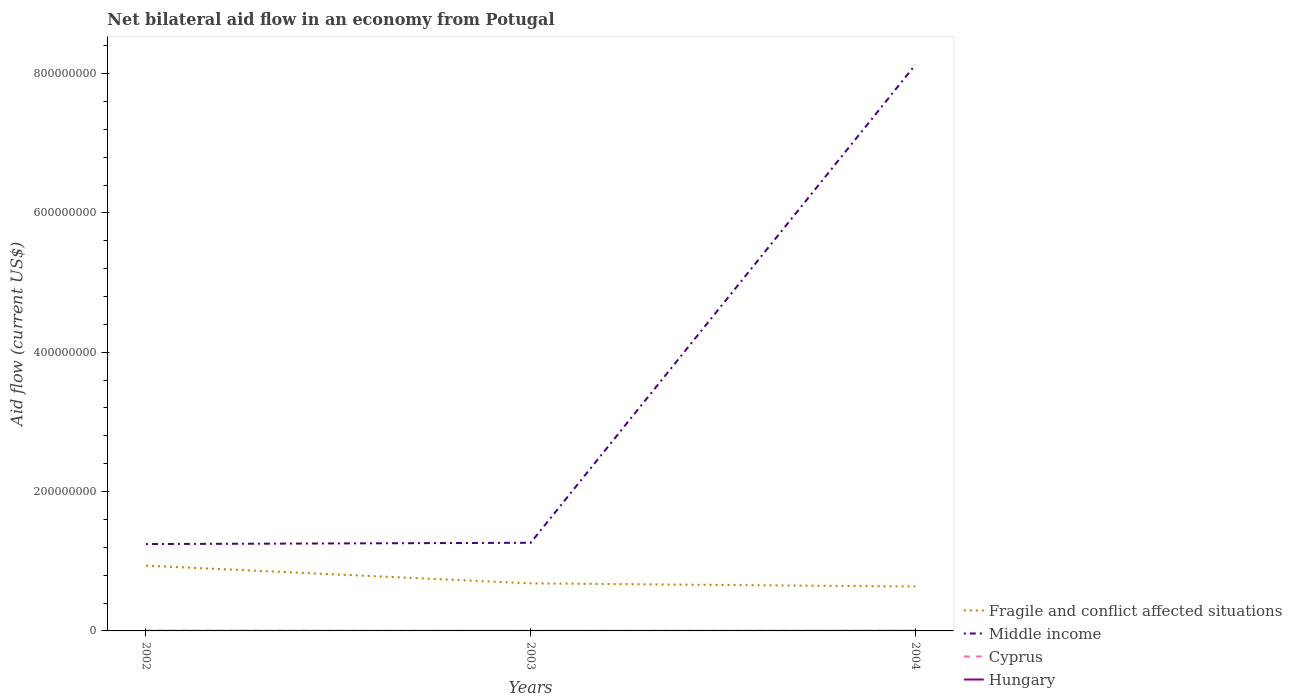Across all years, what is the maximum net bilateral aid flow in Fragile and conflict affected situations?
Provide a short and direct response. 6.37e+07. What is the difference between the highest and the second highest net bilateral aid flow in Fragile and conflict affected situations?
Provide a short and direct response. 3.00e+07. What is the difference between the highest and the lowest net bilateral aid flow in Fragile and conflict affected situations?
Keep it short and to the point. 1. How many lines are there?
Provide a succinct answer. 4. How many years are there in the graph?
Your response must be concise. 3. What is the difference between two consecutive major ticks on the Y-axis?
Provide a short and direct response. 2.00e+08. How many legend labels are there?
Your answer should be compact. 4. What is the title of the graph?
Your answer should be very brief. Net bilateral aid flow in an economy from Potugal. Does "Hong Kong" appear as one of the legend labels in the graph?
Your answer should be very brief. No. What is the label or title of the X-axis?
Ensure brevity in your answer.  Years. What is the Aid flow (current US$) in Fragile and conflict affected situations in 2002?
Your answer should be compact. 9.37e+07. What is the Aid flow (current US$) in Middle income in 2002?
Offer a terse response. 1.25e+08. What is the Aid flow (current US$) of Hungary in 2002?
Make the answer very short. 7.00e+04. What is the Aid flow (current US$) of Fragile and conflict affected situations in 2003?
Give a very brief answer. 6.82e+07. What is the Aid flow (current US$) in Middle income in 2003?
Ensure brevity in your answer.  1.27e+08. What is the Aid flow (current US$) of Fragile and conflict affected situations in 2004?
Give a very brief answer. 6.37e+07. What is the Aid flow (current US$) of Middle income in 2004?
Your answer should be very brief. 8.12e+08. What is the Aid flow (current US$) in Cyprus in 2004?
Provide a short and direct response. 1.10e+05. What is the Aid flow (current US$) in Hungary in 2004?
Give a very brief answer. 8.00e+04. Across all years, what is the maximum Aid flow (current US$) in Fragile and conflict affected situations?
Provide a short and direct response. 9.37e+07. Across all years, what is the maximum Aid flow (current US$) in Middle income?
Give a very brief answer. 8.12e+08. Across all years, what is the maximum Aid flow (current US$) in Cyprus?
Provide a succinct answer. 1.90e+05. Across all years, what is the maximum Aid flow (current US$) in Hungary?
Provide a succinct answer. 8.00e+04. Across all years, what is the minimum Aid flow (current US$) of Fragile and conflict affected situations?
Your answer should be very brief. 6.37e+07. Across all years, what is the minimum Aid flow (current US$) of Middle income?
Your answer should be compact. 1.25e+08. What is the total Aid flow (current US$) in Fragile and conflict affected situations in the graph?
Provide a succinct answer. 2.26e+08. What is the total Aid flow (current US$) in Middle income in the graph?
Keep it short and to the point. 1.06e+09. What is the total Aid flow (current US$) in Cyprus in the graph?
Offer a terse response. 3.30e+05. What is the difference between the Aid flow (current US$) of Fragile and conflict affected situations in 2002 and that in 2003?
Your answer should be compact. 2.54e+07. What is the difference between the Aid flow (current US$) in Middle income in 2002 and that in 2003?
Make the answer very short. -1.84e+06. What is the difference between the Aid flow (current US$) of Cyprus in 2002 and that in 2003?
Make the answer very short. 1.60e+05. What is the difference between the Aid flow (current US$) in Fragile and conflict affected situations in 2002 and that in 2004?
Give a very brief answer. 3.00e+07. What is the difference between the Aid flow (current US$) of Middle income in 2002 and that in 2004?
Give a very brief answer. -6.88e+08. What is the difference between the Aid flow (current US$) of Fragile and conflict affected situations in 2003 and that in 2004?
Ensure brevity in your answer.  4.52e+06. What is the difference between the Aid flow (current US$) of Middle income in 2003 and that in 2004?
Offer a terse response. -6.86e+08. What is the difference between the Aid flow (current US$) of Hungary in 2003 and that in 2004?
Offer a very short reply. -7.00e+04. What is the difference between the Aid flow (current US$) in Fragile and conflict affected situations in 2002 and the Aid flow (current US$) in Middle income in 2003?
Your answer should be very brief. -3.28e+07. What is the difference between the Aid flow (current US$) of Fragile and conflict affected situations in 2002 and the Aid flow (current US$) of Cyprus in 2003?
Keep it short and to the point. 9.36e+07. What is the difference between the Aid flow (current US$) in Fragile and conflict affected situations in 2002 and the Aid flow (current US$) in Hungary in 2003?
Your answer should be very brief. 9.36e+07. What is the difference between the Aid flow (current US$) in Middle income in 2002 and the Aid flow (current US$) in Cyprus in 2003?
Ensure brevity in your answer.  1.25e+08. What is the difference between the Aid flow (current US$) of Middle income in 2002 and the Aid flow (current US$) of Hungary in 2003?
Offer a very short reply. 1.25e+08. What is the difference between the Aid flow (current US$) of Cyprus in 2002 and the Aid flow (current US$) of Hungary in 2003?
Offer a terse response. 1.80e+05. What is the difference between the Aid flow (current US$) in Fragile and conflict affected situations in 2002 and the Aid flow (current US$) in Middle income in 2004?
Ensure brevity in your answer.  -7.19e+08. What is the difference between the Aid flow (current US$) of Fragile and conflict affected situations in 2002 and the Aid flow (current US$) of Cyprus in 2004?
Your answer should be compact. 9.36e+07. What is the difference between the Aid flow (current US$) in Fragile and conflict affected situations in 2002 and the Aid flow (current US$) in Hungary in 2004?
Provide a short and direct response. 9.36e+07. What is the difference between the Aid flow (current US$) of Middle income in 2002 and the Aid flow (current US$) of Cyprus in 2004?
Offer a terse response. 1.25e+08. What is the difference between the Aid flow (current US$) of Middle income in 2002 and the Aid flow (current US$) of Hungary in 2004?
Your response must be concise. 1.25e+08. What is the difference between the Aid flow (current US$) in Cyprus in 2002 and the Aid flow (current US$) in Hungary in 2004?
Make the answer very short. 1.10e+05. What is the difference between the Aid flow (current US$) in Fragile and conflict affected situations in 2003 and the Aid flow (current US$) in Middle income in 2004?
Your response must be concise. -7.44e+08. What is the difference between the Aid flow (current US$) in Fragile and conflict affected situations in 2003 and the Aid flow (current US$) in Cyprus in 2004?
Give a very brief answer. 6.81e+07. What is the difference between the Aid flow (current US$) in Fragile and conflict affected situations in 2003 and the Aid flow (current US$) in Hungary in 2004?
Keep it short and to the point. 6.82e+07. What is the difference between the Aid flow (current US$) in Middle income in 2003 and the Aid flow (current US$) in Cyprus in 2004?
Give a very brief answer. 1.26e+08. What is the difference between the Aid flow (current US$) of Middle income in 2003 and the Aid flow (current US$) of Hungary in 2004?
Give a very brief answer. 1.26e+08. What is the difference between the Aid flow (current US$) of Cyprus in 2003 and the Aid flow (current US$) of Hungary in 2004?
Give a very brief answer. -5.00e+04. What is the average Aid flow (current US$) of Fragile and conflict affected situations per year?
Provide a short and direct response. 7.52e+07. What is the average Aid flow (current US$) of Middle income per year?
Your response must be concise. 3.55e+08. What is the average Aid flow (current US$) in Hungary per year?
Make the answer very short. 5.33e+04. In the year 2002, what is the difference between the Aid flow (current US$) in Fragile and conflict affected situations and Aid flow (current US$) in Middle income?
Provide a succinct answer. -3.10e+07. In the year 2002, what is the difference between the Aid flow (current US$) of Fragile and conflict affected situations and Aid flow (current US$) of Cyprus?
Provide a short and direct response. 9.35e+07. In the year 2002, what is the difference between the Aid flow (current US$) of Fragile and conflict affected situations and Aid flow (current US$) of Hungary?
Your answer should be compact. 9.36e+07. In the year 2002, what is the difference between the Aid flow (current US$) in Middle income and Aid flow (current US$) in Cyprus?
Provide a succinct answer. 1.24e+08. In the year 2002, what is the difference between the Aid flow (current US$) in Middle income and Aid flow (current US$) in Hungary?
Keep it short and to the point. 1.25e+08. In the year 2003, what is the difference between the Aid flow (current US$) in Fragile and conflict affected situations and Aid flow (current US$) in Middle income?
Your answer should be compact. -5.83e+07. In the year 2003, what is the difference between the Aid flow (current US$) of Fragile and conflict affected situations and Aid flow (current US$) of Cyprus?
Your answer should be compact. 6.82e+07. In the year 2003, what is the difference between the Aid flow (current US$) of Fragile and conflict affected situations and Aid flow (current US$) of Hungary?
Offer a terse response. 6.82e+07. In the year 2003, what is the difference between the Aid flow (current US$) of Middle income and Aid flow (current US$) of Cyprus?
Make the answer very short. 1.26e+08. In the year 2003, what is the difference between the Aid flow (current US$) of Middle income and Aid flow (current US$) of Hungary?
Provide a succinct answer. 1.26e+08. In the year 2003, what is the difference between the Aid flow (current US$) of Cyprus and Aid flow (current US$) of Hungary?
Offer a very short reply. 2.00e+04. In the year 2004, what is the difference between the Aid flow (current US$) in Fragile and conflict affected situations and Aid flow (current US$) in Middle income?
Ensure brevity in your answer.  -7.49e+08. In the year 2004, what is the difference between the Aid flow (current US$) of Fragile and conflict affected situations and Aid flow (current US$) of Cyprus?
Offer a terse response. 6.36e+07. In the year 2004, what is the difference between the Aid flow (current US$) in Fragile and conflict affected situations and Aid flow (current US$) in Hungary?
Offer a very short reply. 6.36e+07. In the year 2004, what is the difference between the Aid flow (current US$) of Middle income and Aid flow (current US$) of Cyprus?
Offer a very short reply. 8.12e+08. In the year 2004, what is the difference between the Aid flow (current US$) in Middle income and Aid flow (current US$) in Hungary?
Your answer should be compact. 8.12e+08. What is the ratio of the Aid flow (current US$) of Fragile and conflict affected situations in 2002 to that in 2003?
Your answer should be very brief. 1.37. What is the ratio of the Aid flow (current US$) of Middle income in 2002 to that in 2003?
Your response must be concise. 0.99. What is the ratio of the Aid flow (current US$) of Cyprus in 2002 to that in 2003?
Provide a short and direct response. 6.33. What is the ratio of the Aid flow (current US$) in Hungary in 2002 to that in 2003?
Your response must be concise. 7. What is the ratio of the Aid flow (current US$) in Fragile and conflict affected situations in 2002 to that in 2004?
Your answer should be very brief. 1.47. What is the ratio of the Aid flow (current US$) of Middle income in 2002 to that in 2004?
Your response must be concise. 0.15. What is the ratio of the Aid flow (current US$) in Cyprus in 2002 to that in 2004?
Keep it short and to the point. 1.73. What is the ratio of the Aid flow (current US$) of Fragile and conflict affected situations in 2003 to that in 2004?
Give a very brief answer. 1.07. What is the ratio of the Aid flow (current US$) in Middle income in 2003 to that in 2004?
Offer a very short reply. 0.16. What is the ratio of the Aid flow (current US$) in Cyprus in 2003 to that in 2004?
Keep it short and to the point. 0.27. What is the difference between the highest and the second highest Aid flow (current US$) in Fragile and conflict affected situations?
Your response must be concise. 2.54e+07. What is the difference between the highest and the second highest Aid flow (current US$) of Middle income?
Your answer should be compact. 6.86e+08. What is the difference between the highest and the second highest Aid flow (current US$) of Cyprus?
Your response must be concise. 8.00e+04. What is the difference between the highest and the lowest Aid flow (current US$) of Fragile and conflict affected situations?
Offer a very short reply. 3.00e+07. What is the difference between the highest and the lowest Aid flow (current US$) of Middle income?
Your answer should be compact. 6.88e+08. What is the difference between the highest and the lowest Aid flow (current US$) in Cyprus?
Provide a succinct answer. 1.60e+05. 